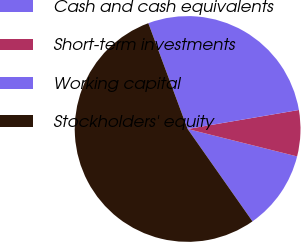Convert chart. <chart><loc_0><loc_0><loc_500><loc_500><pie_chart><fcel>Cash and cash equivalents<fcel>Short-term investments<fcel>Working capital<fcel>Stockholders' equity<nl><fcel>11.35%<fcel>6.6%<fcel>27.97%<fcel>54.08%<nl></chart> 